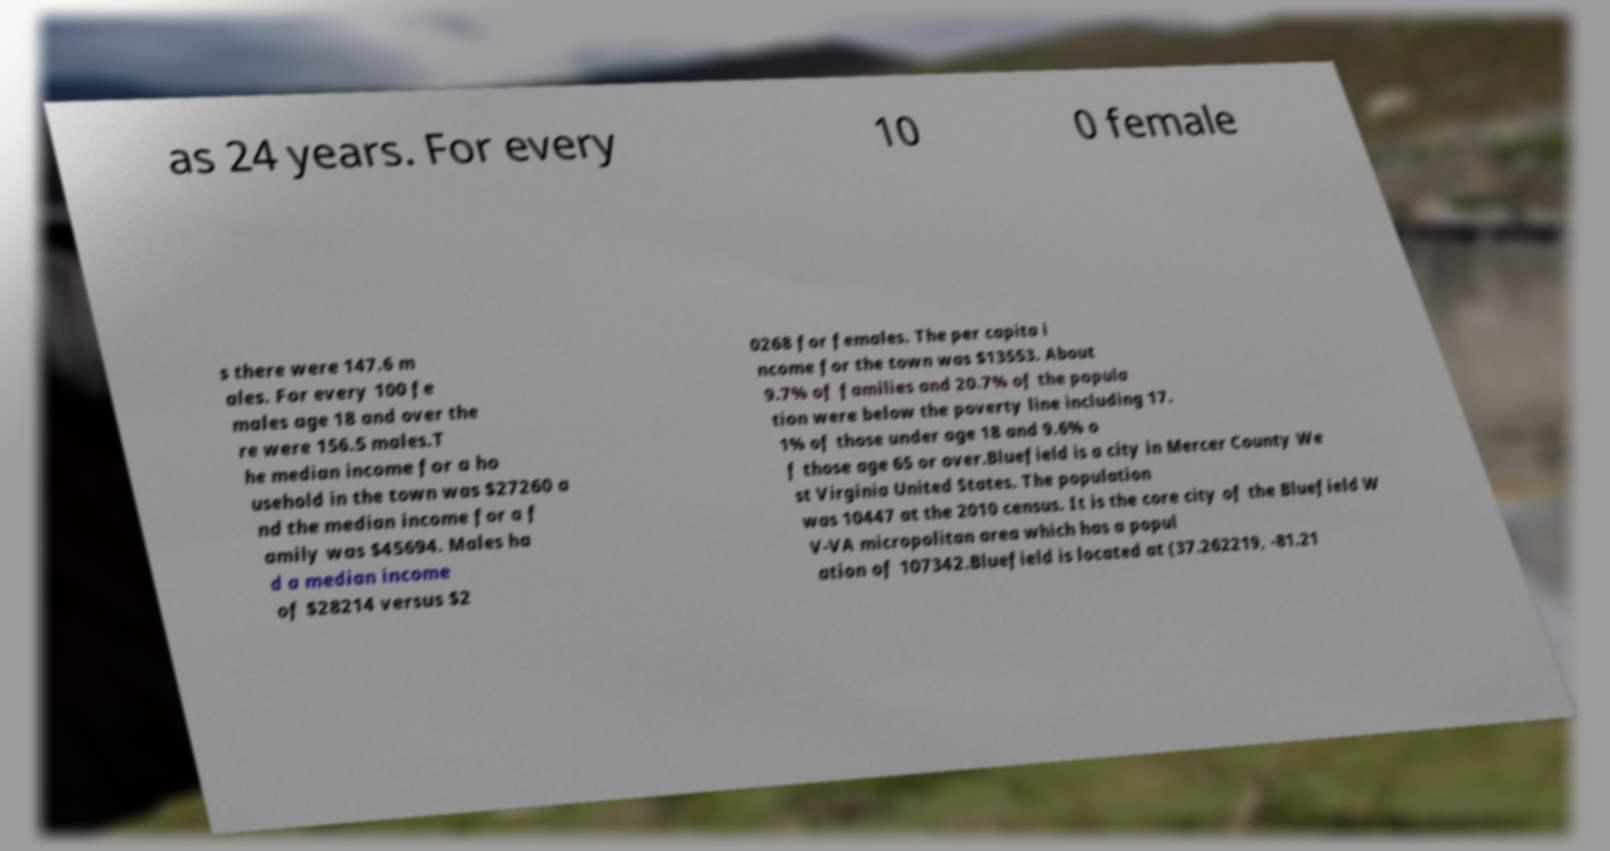For documentation purposes, I need the text within this image transcribed. Could you provide that? as 24 years. For every 10 0 female s there were 147.6 m ales. For every 100 fe males age 18 and over the re were 156.5 males.T he median income for a ho usehold in the town was $27260 a nd the median income for a f amily was $45694. Males ha d a median income of $28214 versus $2 0268 for females. The per capita i ncome for the town was $13553. About 9.7% of families and 20.7% of the popula tion were below the poverty line including 17. 1% of those under age 18 and 9.6% o f those age 65 or over.Bluefield is a city in Mercer County We st Virginia United States. The population was 10447 at the 2010 census. It is the core city of the Bluefield W V-VA micropolitan area which has a popul ation of 107342.Bluefield is located at (37.262219, -81.21 